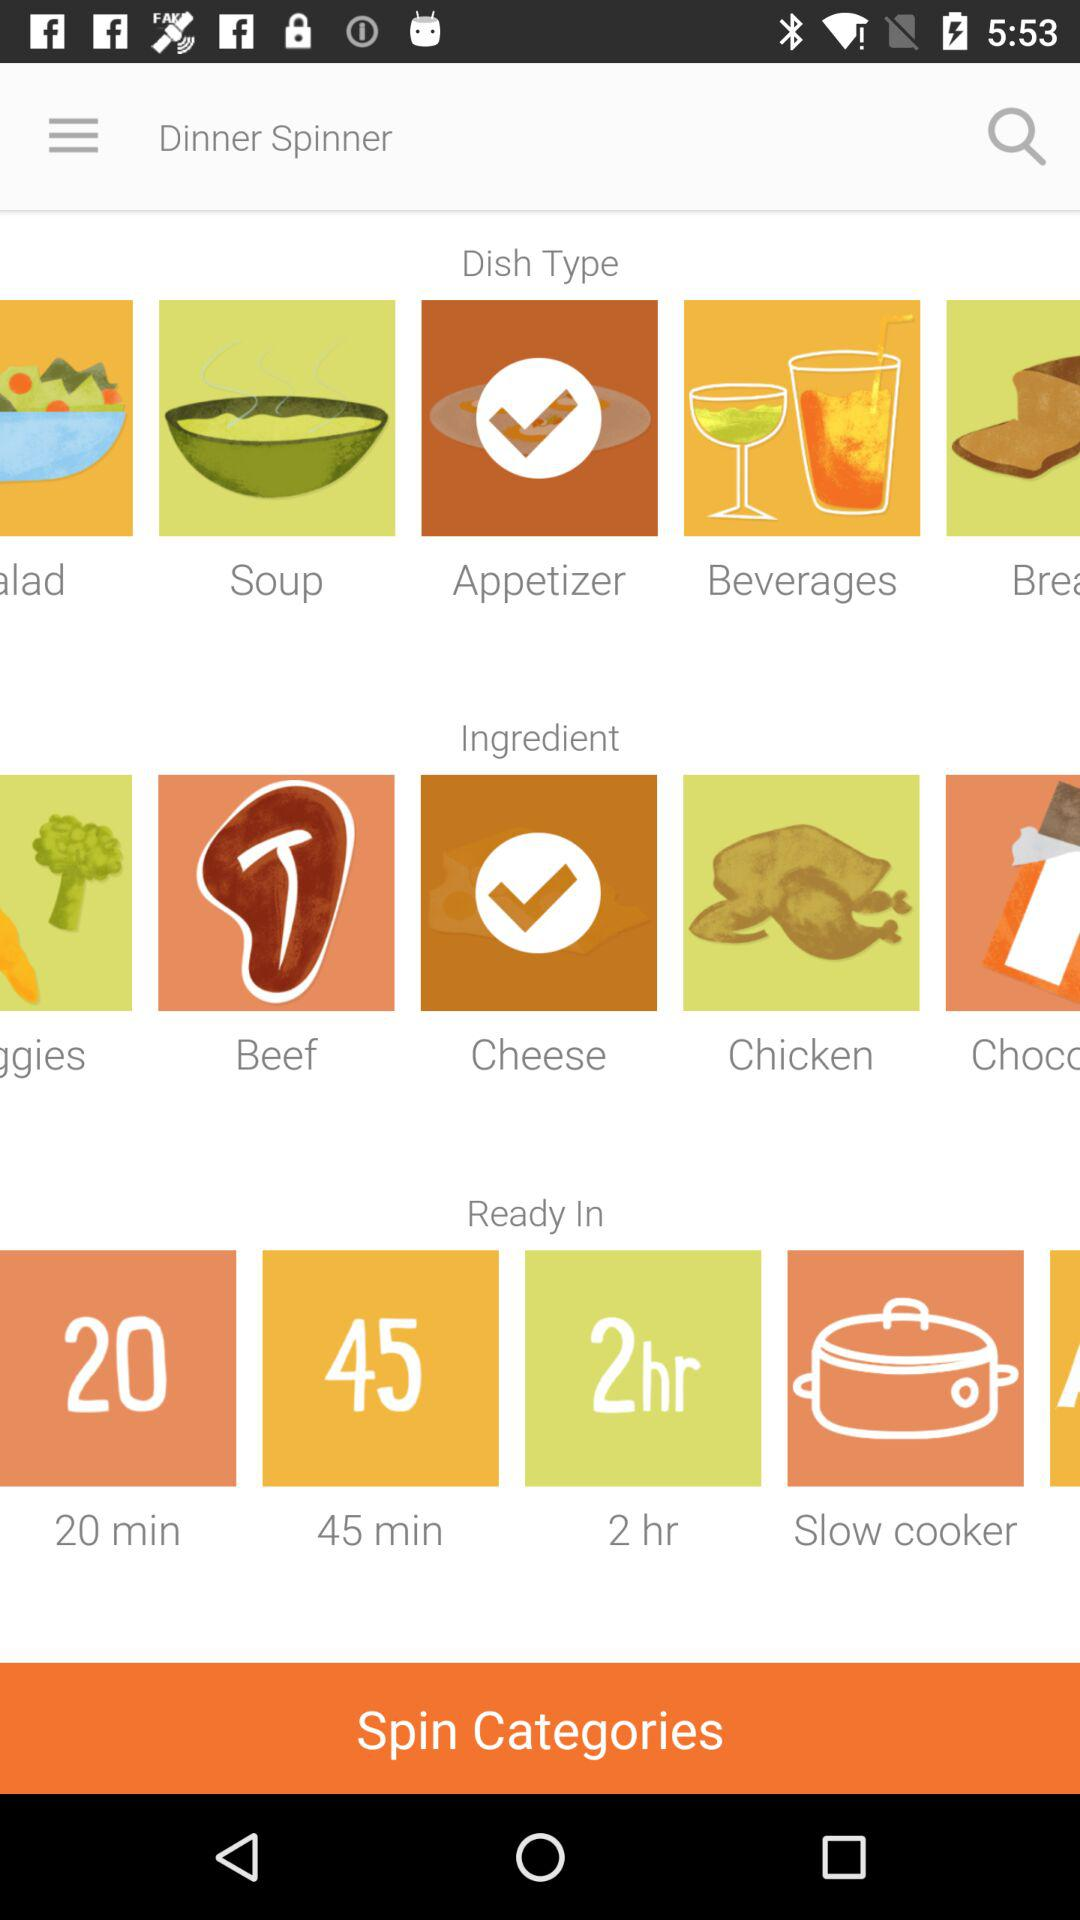What are the available time durations? The available time durations are 20 minutes, 45 minutes and 2 hours. 